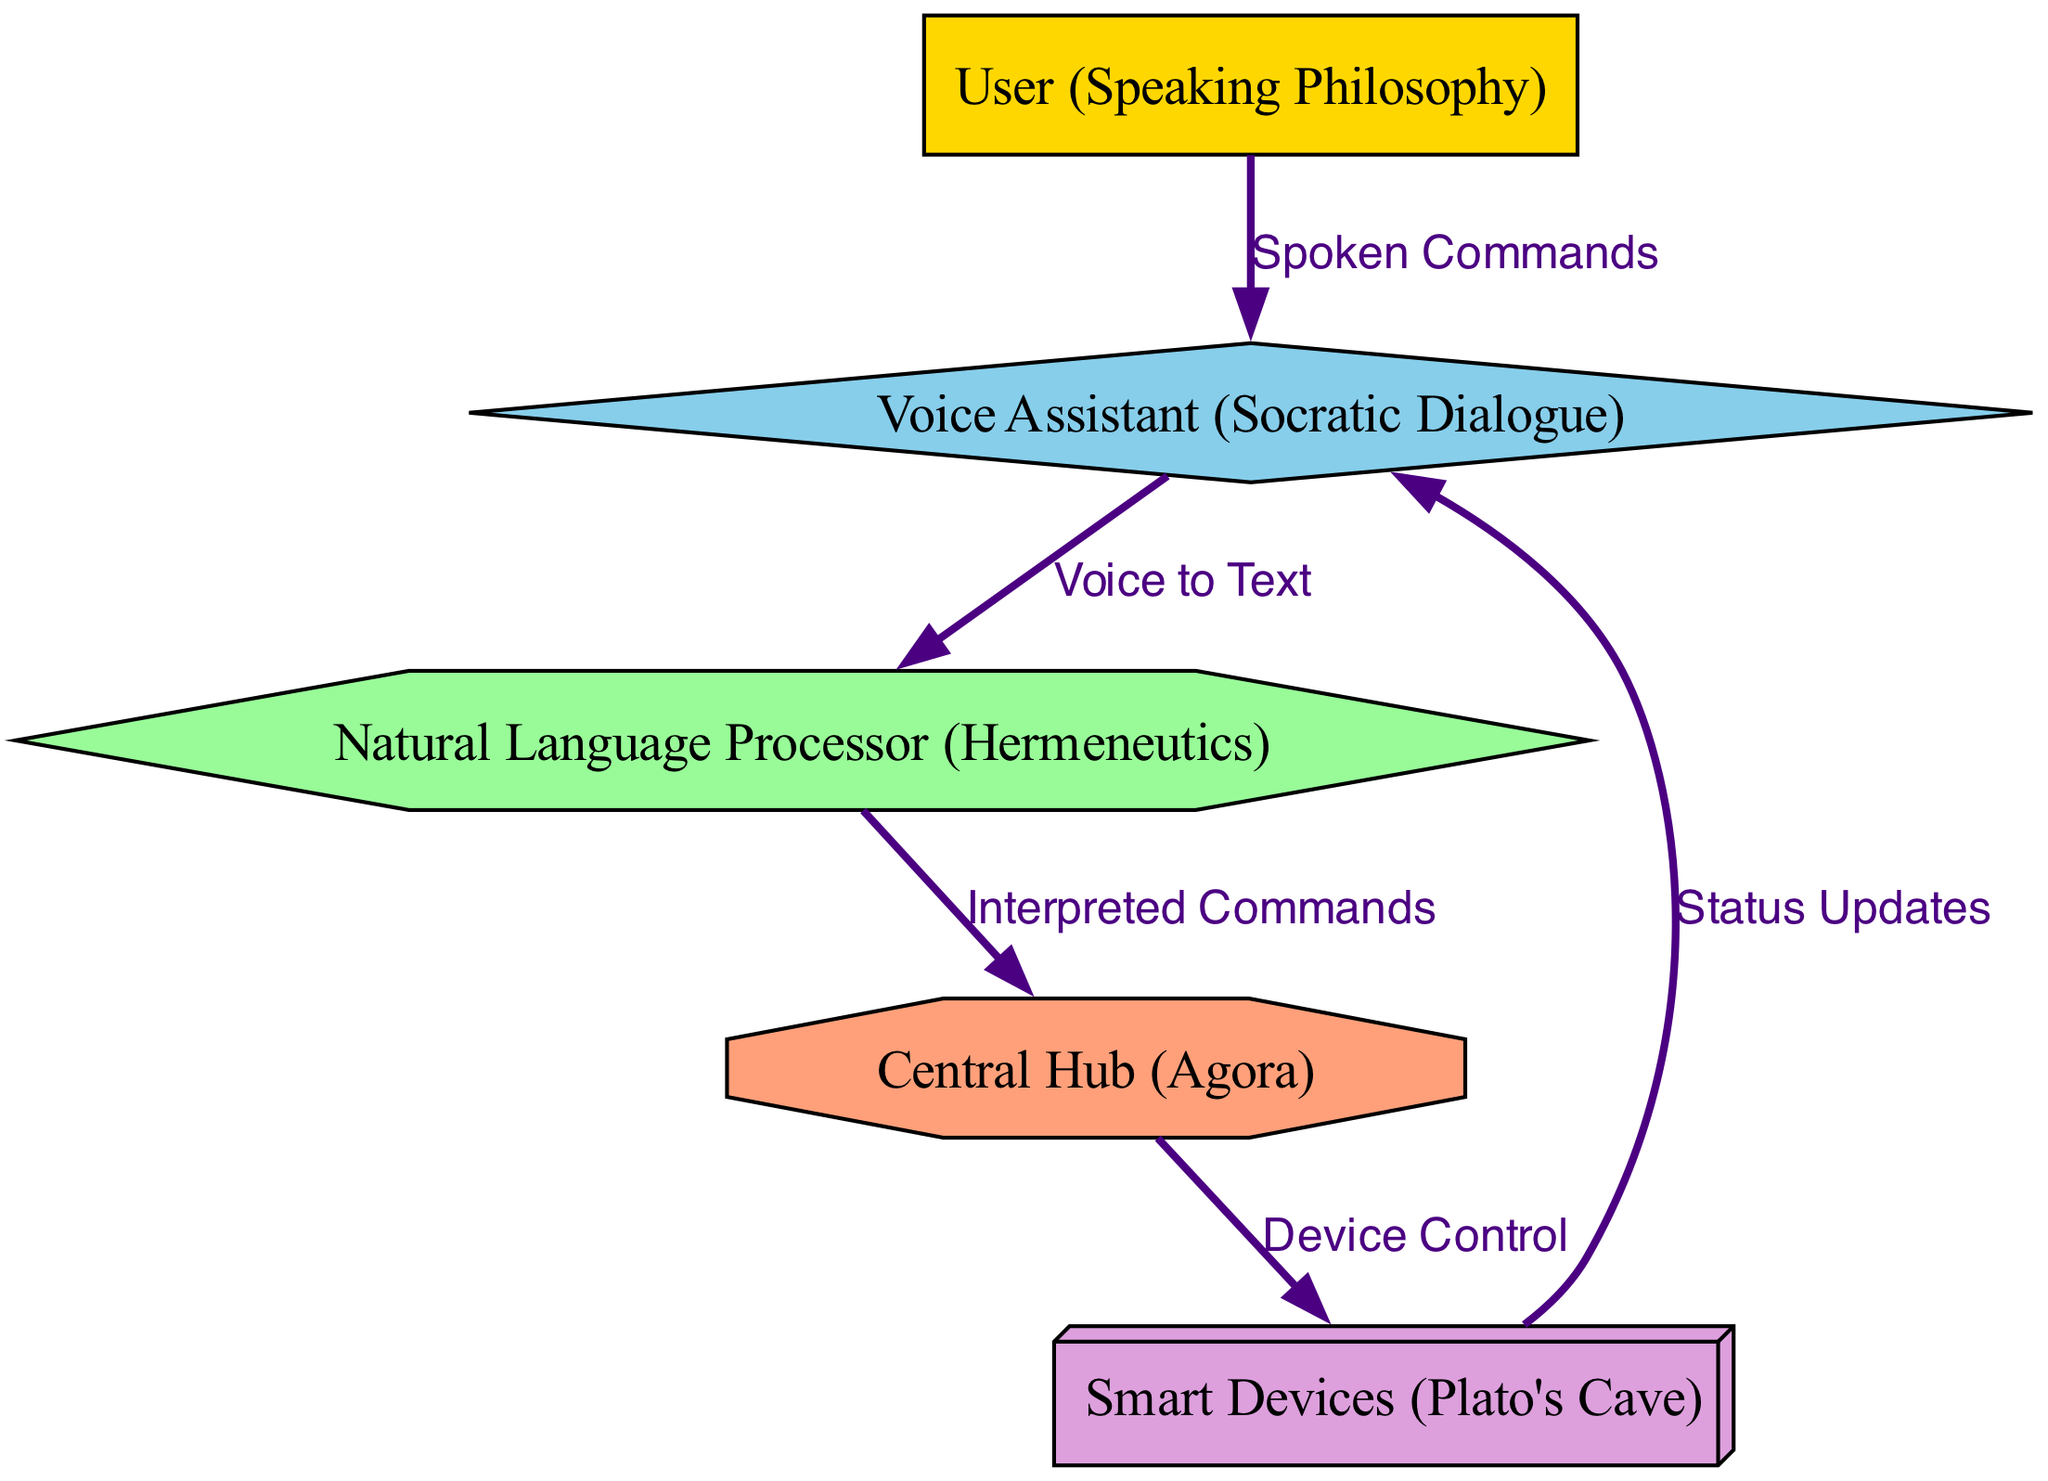What is the total number of nodes in the diagram? The diagram contains five nodes: User, Voice Assistant, NLP Engine, Central Hub, and Smart Devices. By counting these distinct nodes, we find the total.
Answer: 5 Which node represents the user in the diagram? The node labeled "User (Speaking Philosophy)" represents the user, which can be identified by its label in the diagram.
Answer: User (Speaking Philosophy) How many edges connect the Voice Assistant to other nodes? The Voice Assistant has three outgoing edges: one to the NLP Engine, one to the Smart Devices (for status updates), and an incoming edge from the User. Thus, it has two outgoing connections.
Answer: 2 What type of command does the User issue to the Voice Assistant? The User issues "Spoken Commands" to the Voice Assistant. This is indicated as the label of the edge connecting these two nodes.
Answer: Spoken Commands What is the purpose of the Central Hub in the diagram? The Central Hub serves to control smart devices as indicated by the edge label "Device Control." It acts as the intermediary between interpreted commands and their execution in devices.
Answer: Device Control Which philosophical concept is associated with the NLP Engine? The NLP Engine is associated with "Hermeneutics," as specified in the node's label in the diagram.
Answer: Hermeneutics Which node receives status updates? The node that receives status updates is the Voice Assistant, which is indicated by the edge that connects Smart Devices to Voice Assistant.
Answer: Voice Assistant How is the relationship between the NLP Engine and the Central Hub established? The relationship is established through the edge labeled "Interpreted Commands," indicating that valid outputs from the NLP Engine are sent to the Central Hub for further processing.
Answer: Interpreted Commands What role does the Smart Devices node play in the diagram? The Smart Devices node plays the role of execution, controlled by commands interpreted and sent from the Central Hub, as evidenced by the direction of the edges connected to it.
Answer: Execution 